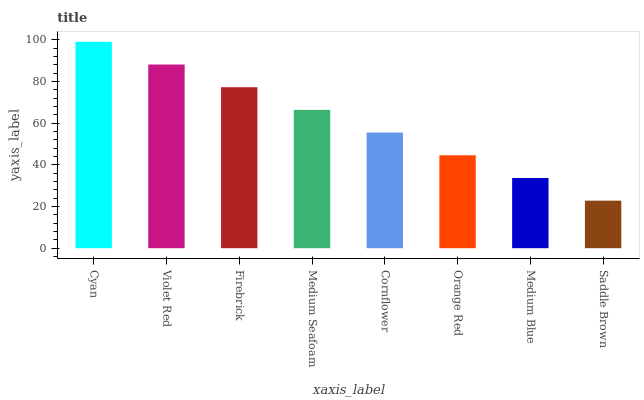Is Violet Red the minimum?
Answer yes or no. No. Is Violet Red the maximum?
Answer yes or no. No. Is Cyan greater than Violet Red?
Answer yes or no. Yes. Is Violet Red less than Cyan?
Answer yes or no. Yes. Is Violet Red greater than Cyan?
Answer yes or no. No. Is Cyan less than Violet Red?
Answer yes or no. No. Is Medium Seafoam the high median?
Answer yes or no. Yes. Is Cornflower the low median?
Answer yes or no. Yes. Is Orange Red the high median?
Answer yes or no. No. Is Saddle Brown the low median?
Answer yes or no. No. 